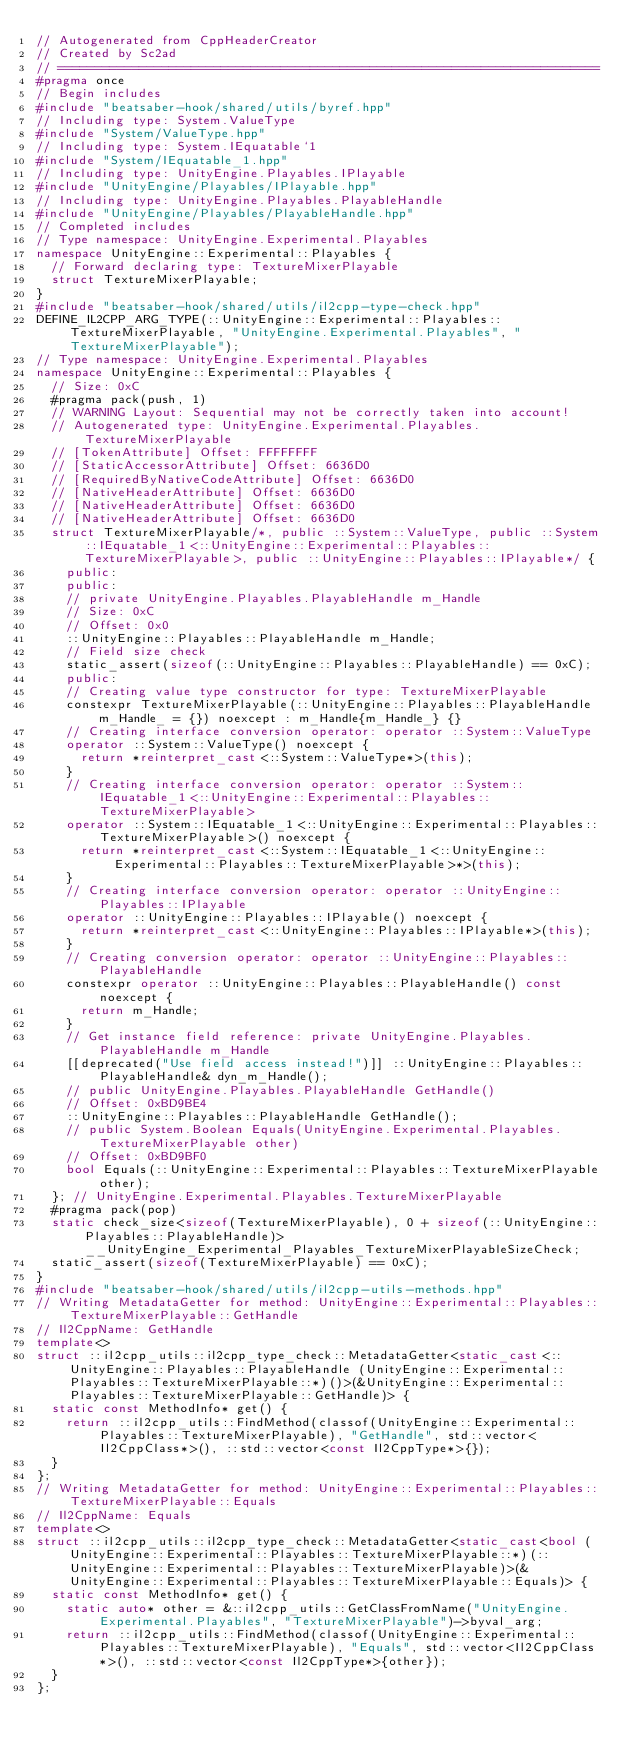Convert code to text. <code><loc_0><loc_0><loc_500><loc_500><_C++_>// Autogenerated from CppHeaderCreator
// Created by Sc2ad
// =========================================================================
#pragma once
// Begin includes
#include "beatsaber-hook/shared/utils/byref.hpp"
// Including type: System.ValueType
#include "System/ValueType.hpp"
// Including type: System.IEquatable`1
#include "System/IEquatable_1.hpp"
// Including type: UnityEngine.Playables.IPlayable
#include "UnityEngine/Playables/IPlayable.hpp"
// Including type: UnityEngine.Playables.PlayableHandle
#include "UnityEngine/Playables/PlayableHandle.hpp"
// Completed includes
// Type namespace: UnityEngine.Experimental.Playables
namespace UnityEngine::Experimental::Playables {
  // Forward declaring type: TextureMixerPlayable
  struct TextureMixerPlayable;
}
#include "beatsaber-hook/shared/utils/il2cpp-type-check.hpp"
DEFINE_IL2CPP_ARG_TYPE(::UnityEngine::Experimental::Playables::TextureMixerPlayable, "UnityEngine.Experimental.Playables", "TextureMixerPlayable");
// Type namespace: UnityEngine.Experimental.Playables
namespace UnityEngine::Experimental::Playables {
  // Size: 0xC
  #pragma pack(push, 1)
  // WARNING Layout: Sequential may not be correctly taken into account!
  // Autogenerated type: UnityEngine.Experimental.Playables.TextureMixerPlayable
  // [TokenAttribute] Offset: FFFFFFFF
  // [StaticAccessorAttribute] Offset: 6636D0
  // [RequiredByNativeCodeAttribute] Offset: 6636D0
  // [NativeHeaderAttribute] Offset: 6636D0
  // [NativeHeaderAttribute] Offset: 6636D0
  // [NativeHeaderAttribute] Offset: 6636D0
  struct TextureMixerPlayable/*, public ::System::ValueType, public ::System::IEquatable_1<::UnityEngine::Experimental::Playables::TextureMixerPlayable>, public ::UnityEngine::Playables::IPlayable*/ {
    public:
    public:
    // private UnityEngine.Playables.PlayableHandle m_Handle
    // Size: 0xC
    // Offset: 0x0
    ::UnityEngine::Playables::PlayableHandle m_Handle;
    // Field size check
    static_assert(sizeof(::UnityEngine::Playables::PlayableHandle) == 0xC);
    public:
    // Creating value type constructor for type: TextureMixerPlayable
    constexpr TextureMixerPlayable(::UnityEngine::Playables::PlayableHandle m_Handle_ = {}) noexcept : m_Handle{m_Handle_} {}
    // Creating interface conversion operator: operator ::System::ValueType
    operator ::System::ValueType() noexcept {
      return *reinterpret_cast<::System::ValueType*>(this);
    }
    // Creating interface conversion operator: operator ::System::IEquatable_1<::UnityEngine::Experimental::Playables::TextureMixerPlayable>
    operator ::System::IEquatable_1<::UnityEngine::Experimental::Playables::TextureMixerPlayable>() noexcept {
      return *reinterpret_cast<::System::IEquatable_1<::UnityEngine::Experimental::Playables::TextureMixerPlayable>*>(this);
    }
    // Creating interface conversion operator: operator ::UnityEngine::Playables::IPlayable
    operator ::UnityEngine::Playables::IPlayable() noexcept {
      return *reinterpret_cast<::UnityEngine::Playables::IPlayable*>(this);
    }
    // Creating conversion operator: operator ::UnityEngine::Playables::PlayableHandle
    constexpr operator ::UnityEngine::Playables::PlayableHandle() const noexcept {
      return m_Handle;
    }
    // Get instance field reference: private UnityEngine.Playables.PlayableHandle m_Handle
    [[deprecated("Use field access instead!")]] ::UnityEngine::Playables::PlayableHandle& dyn_m_Handle();
    // public UnityEngine.Playables.PlayableHandle GetHandle()
    // Offset: 0xBD9BE4
    ::UnityEngine::Playables::PlayableHandle GetHandle();
    // public System.Boolean Equals(UnityEngine.Experimental.Playables.TextureMixerPlayable other)
    // Offset: 0xBD9BF0
    bool Equals(::UnityEngine::Experimental::Playables::TextureMixerPlayable other);
  }; // UnityEngine.Experimental.Playables.TextureMixerPlayable
  #pragma pack(pop)
  static check_size<sizeof(TextureMixerPlayable), 0 + sizeof(::UnityEngine::Playables::PlayableHandle)> __UnityEngine_Experimental_Playables_TextureMixerPlayableSizeCheck;
  static_assert(sizeof(TextureMixerPlayable) == 0xC);
}
#include "beatsaber-hook/shared/utils/il2cpp-utils-methods.hpp"
// Writing MetadataGetter for method: UnityEngine::Experimental::Playables::TextureMixerPlayable::GetHandle
// Il2CppName: GetHandle
template<>
struct ::il2cpp_utils::il2cpp_type_check::MetadataGetter<static_cast<::UnityEngine::Playables::PlayableHandle (UnityEngine::Experimental::Playables::TextureMixerPlayable::*)()>(&UnityEngine::Experimental::Playables::TextureMixerPlayable::GetHandle)> {
  static const MethodInfo* get() {
    return ::il2cpp_utils::FindMethod(classof(UnityEngine::Experimental::Playables::TextureMixerPlayable), "GetHandle", std::vector<Il2CppClass*>(), ::std::vector<const Il2CppType*>{});
  }
};
// Writing MetadataGetter for method: UnityEngine::Experimental::Playables::TextureMixerPlayable::Equals
// Il2CppName: Equals
template<>
struct ::il2cpp_utils::il2cpp_type_check::MetadataGetter<static_cast<bool (UnityEngine::Experimental::Playables::TextureMixerPlayable::*)(::UnityEngine::Experimental::Playables::TextureMixerPlayable)>(&UnityEngine::Experimental::Playables::TextureMixerPlayable::Equals)> {
  static const MethodInfo* get() {
    static auto* other = &::il2cpp_utils::GetClassFromName("UnityEngine.Experimental.Playables", "TextureMixerPlayable")->byval_arg;
    return ::il2cpp_utils::FindMethod(classof(UnityEngine::Experimental::Playables::TextureMixerPlayable), "Equals", std::vector<Il2CppClass*>(), ::std::vector<const Il2CppType*>{other});
  }
};
</code> 